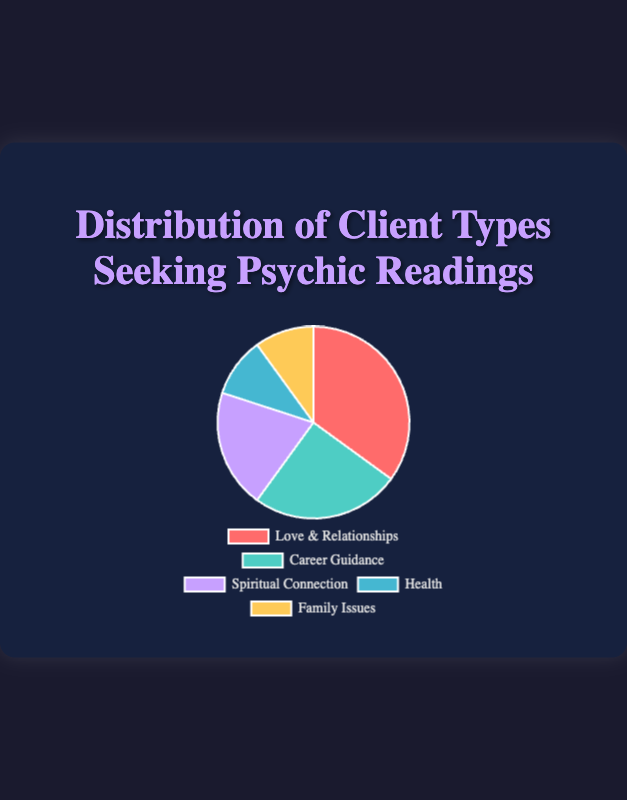What percentage of clients seek guidance for Career Guidance? Look at the category labeled "Career Guidance" on the pie chart. The percentage next to it should be visible. It is 25%.
Answer: 25% Which client type has the highest percentage in the distribution? Identify the category with the largest section in the pie chart, which is "Love & Relationships" with 35%.
Answer: Love & Relationships Are there any client types that have the same percentage? If so, which ones? Locate categories with equal-sized sections in the pie chart. Both "Health" and "Family Issues" have a percentage of 10%.
Answer: Health and Family Issues How much greater is the percentage of clients seeking Psychic Readings for Love & Relationships compared to those concerning Health? Subtract the percentage of "Health" from "Love & Relationships": 35% - 10% = 25%.
Answer: 25% What is the combined percentage of clients seeking guidance for Spiritual Connection and Career Guidance? Add the percentages for "Spiritual Connection" (20%) and "Career Guidance" (25%): 20% + 25% = 45%.
Answer: 45% Which client type has a smaller percentage, Health or Spiritual Connection? Compare the slices for "Health" (10%) and "Spiritual Connection" (20%). "Health" has a smaller percentage of 10%.
Answer: Health What percentage of the clients is seeking guidance either for Health or Family Issues? Add the percentages of "Health" (10%) and "Family Issues" (10%): 10% + 10% = 20%.
Answer: 20% If a new category "Education" is introduced with 5%, would the percentage for any current category still be higher than Education? If so, which one? Compare the new percentage (5%) with every existing category. All existing percentages (35%, 25%, 20%, 10%, 10%) are higher than 5%.
Answer: Love & Relationships, Career Guidance, Spiritual Connection, Health, Family Issues Which color corresponds to the category "Spiritual Connection"? Identify the color directly associated with "Spiritual Connection" on the pie chart, which is purple.
Answer: purple What is the average percentage of clients seeking guidance for Love & Relationships, Career Guidance, and Spiritual Connection? Add the percentages for "Love & Relationships" (35%), "Career Guidance" (25%), and "Spiritual Connection" (20%), then divide by 3: (35% + 25% + 20%) / 3 = 26.67%.
Answer: 26.67% 